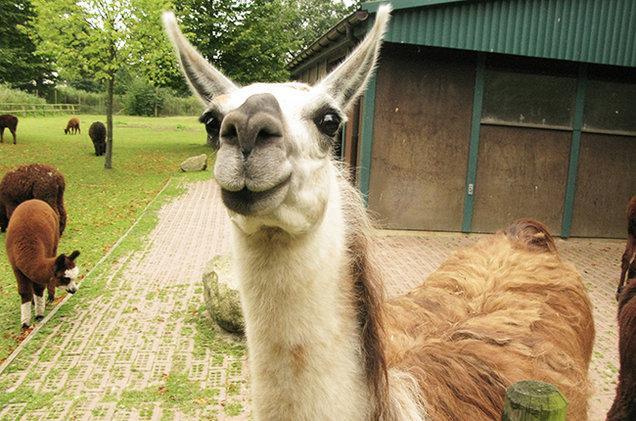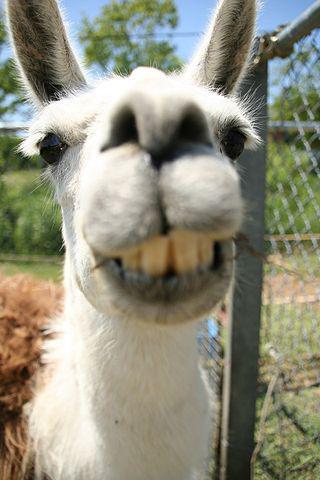The first image is the image on the left, the second image is the image on the right. Analyze the images presented: Is the assertion "Each image features one llama in the foreground, and the righthand llama looks at the camera with a toothy smile." valid? Answer yes or no. Yes. The first image is the image on the left, the second image is the image on the right. Given the left and right images, does the statement "In the image on the right, the llama's eyes are obscured." hold true? Answer yes or no. No. 